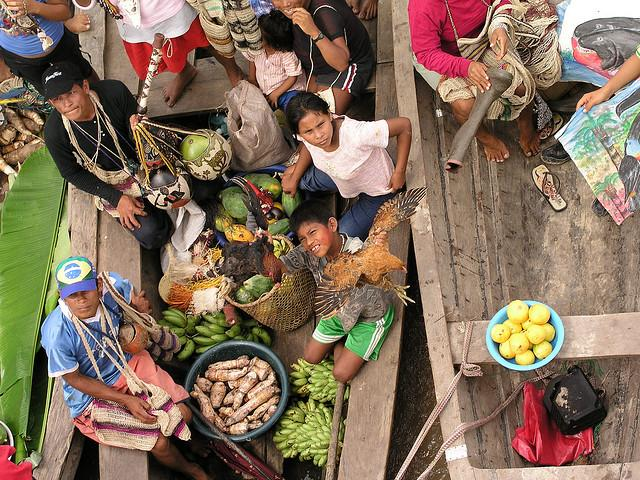Where are the persons here headed?

Choices:
A) casinos
B) bathrooms
C) villas
D) market market 